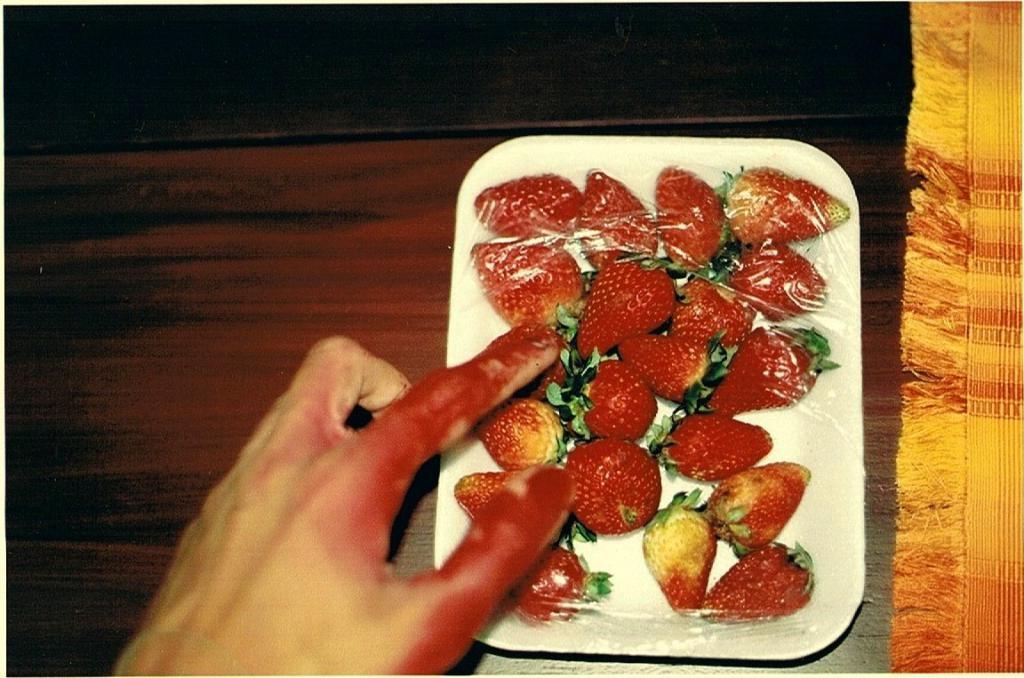Can you describe this image briefly? In the image I can see a tray in which there are some strawberries and also I can see a person hand. 